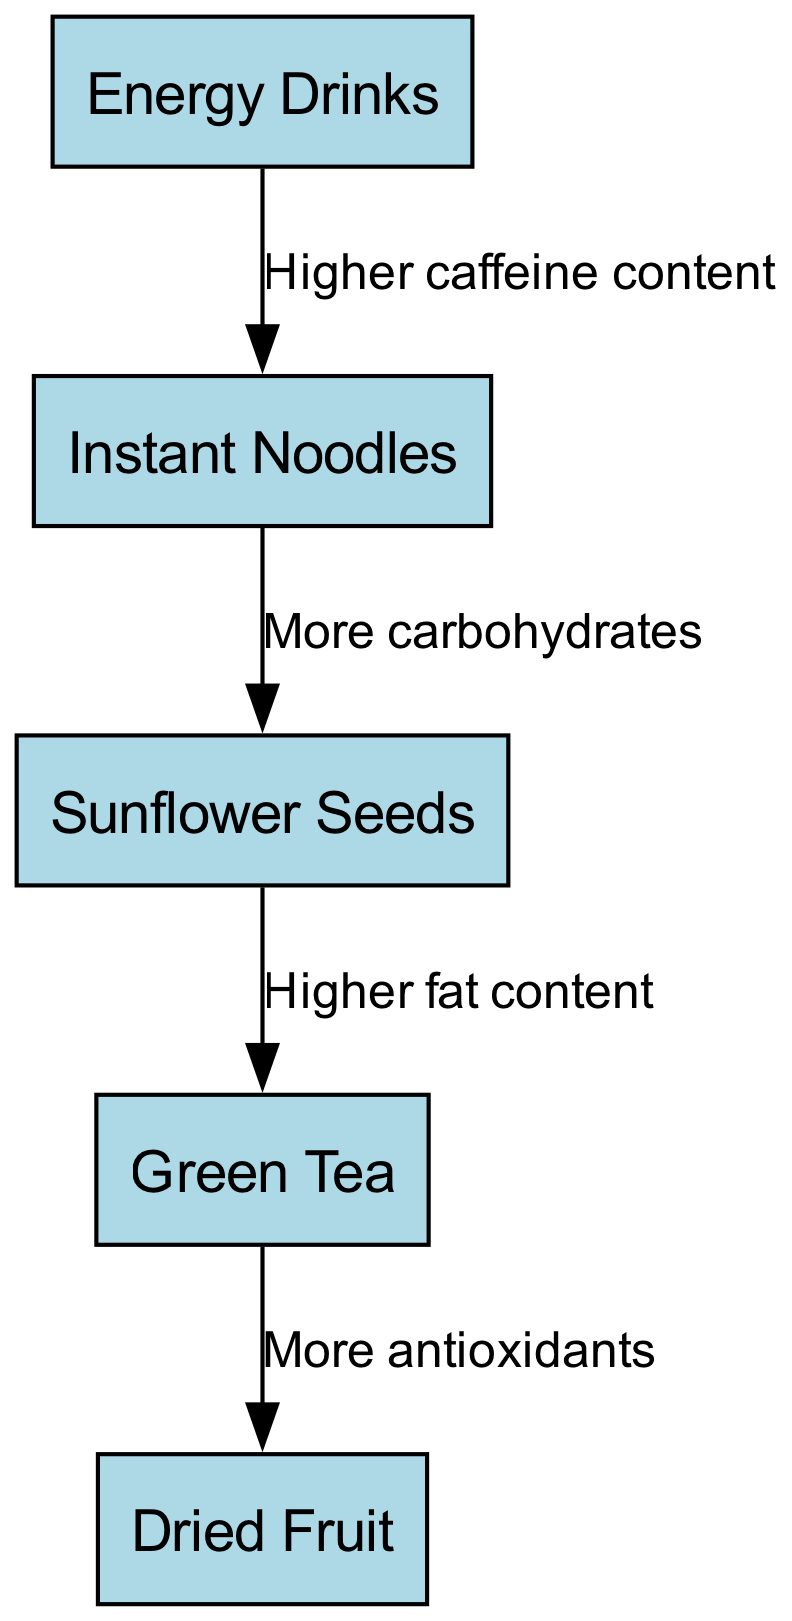How many nodes are in the diagram? The diagram contains five distinct items that can be classified as nodes, which are Energy Drinks, Instant Noodles, Sunflower Seeds, Green Tea, and Dried Fruit.
Answer: 5 Which snack has the highest caffeine content? According to the edges connecting the nodes, Energy Drinks is noted to have a higher caffeine content compared to the other snacks, as it is the source in the first edge leading to Instant Noodles.
Answer: Energy Drinks What is the relationship between Instant Noodles and Sunflower Seeds? The edge connecting Instant Noodles to Sunflower Seeds indicates that Instant Noodles provide more carbohydrates, meaning they are consumed in greater quantities for energy.
Answer: More carbohydrates What snack is the final node in the chain? Following the sequence of the edges from one node to another, the last snack mentioned, which does not lead to another, is Dried Fruit.
Answer: Dried Fruit Which node has an edge labeled 'More antioxidants'? By examining the edges, Green Tea connects to Dried Fruit with the label 'More antioxidants', indicating this relationship between the two snacks.
Answer: Green Tea If you consume Sunflower Seeds, what drink would you likely have next for higher fat content? The edge indicates that Sunflower Seeds lead to Green Tea, known for its higher fat content, meaning consuming Sunflower Seeds may lead to choosing Green Tea next.
Answer: Green Tea Which two snacks are directly related through more carbohydrates? Directly from the diagram, the only snacks connected specifically by the edge labeled 'More carbohydrates' are Instant Noodles and Sunflower Seeds.
Answer: Instant Noodles and Sunflower Seeds What is the connection between Green Tea and Dried Fruit? Green Tea leads to Dried Fruit according to the last edge which emphasizes the connection of increased antioxidants found in Dried Fruit.
Answer: More antioxidants 